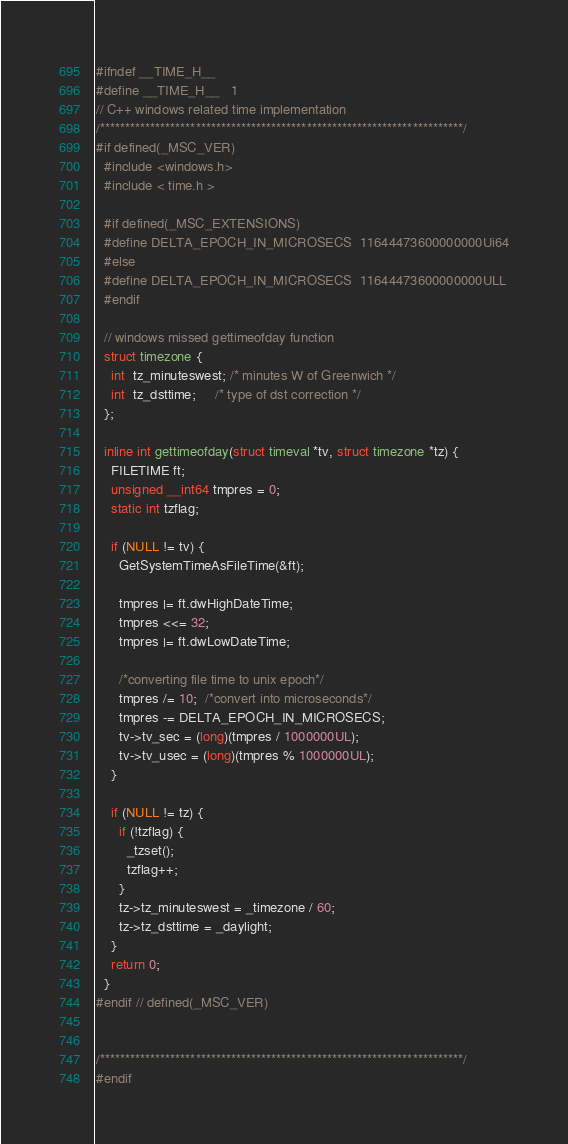Convert code to text. <code><loc_0><loc_0><loc_500><loc_500><_C_>#ifndef __TIME_H__
#define __TIME_H__   1
// C++ windows related time implementation
/************************************************************************/
#if defined(_MSC_VER)
  #include <windows.h>
  #include < time.h >
  
  #if defined(_MSC_EXTENSIONS)
  #define DELTA_EPOCH_IN_MICROSECS  11644473600000000Ui64
  #else
  #define DELTA_EPOCH_IN_MICROSECS  11644473600000000ULL
  #endif
  
  // windows missed gettimeofday function
  struct timezone {
    int  tz_minuteswest; /* minutes W of Greenwich */
    int  tz_dsttime;     /* type of dst correction */
  };
  
  inline int gettimeofday(struct timeval *tv, struct timezone *tz) {
    FILETIME ft;
    unsigned __int64 tmpres = 0;
    static int tzflag;
  
    if (NULL != tv) {
      GetSystemTimeAsFileTime(&ft);
  
      tmpres |= ft.dwHighDateTime;
      tmpres <<= 32;
      tmpres |= ft.dwLowDateTime;
  
      /*converting file time to unix epoch*/
      tmpres /= 10;  /*convert into microseconds*/
      tmpres -= DELTA_EPOCH_IN_MICROSECS;
      tv->tv_sec = (long)(tmpres / 1000000UL);
      tv->tv_usec = (long)(tmpres % 1000000UL);
    }
  
    if (NULL != tz) {
      if (!tzflag) {
        _tzset();
        tzflag++;
      }
      tz->tz_minuteswest = _timezone / 60;
      tz->tz_dsttime = _daylight;
    }
    return 0;
  }
#endif // defined(_MSC_VER)


/************************************************************************/
#endif

</code> 